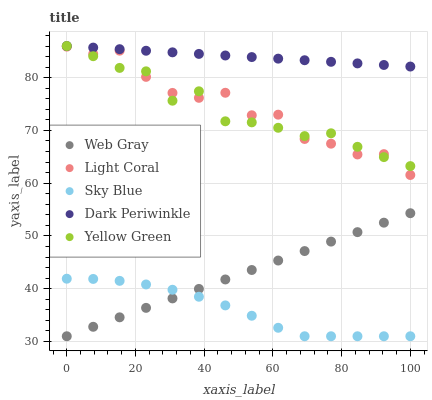Does Sky Blue have the minimum area under the curve?
Answer yes or no. Yes. Does Dark Periwinkle have the maximum area under the curve?
Answer yes or no. Yes. Does Web Gray have the minimum area under the curve?
Answer yes or no. No. Does Web Gray have the maximum area under the curve?
Answer yes or no. No. Is Dark Periwinkle the smoothest?
Answer yes or no. Yes. Is Light Coral the roughest?
Answer yes or no. Yes. Is Sky Blue the smoothest?
Answer yes or no. No. Is Sky Blue the roughest?
Answer yes or no. No. Does Sky Blue have the lowest value?
Answer yes or no. Yes. Does Dark Periwinkle have the lowest value?
Answer yes or no. No. Does Yellow Green have the highest value?
Answer yes or no. Yes. Does Web Gray have the highest value?
Answer yes or no. No. Is Sky Blue less than Dark Periwinkle?
Answer yes or no. Yes. Is Dark Periwinkle greater than Sky Blue?
Answer yes or no. Yes. Does Sky Blue intersect Web Gray?
Answer yes or no. Yes. Is Sky Blue less than Web Gray?
Answer yes or no. No. Is Sky Blue greater than Web Gray?
Answer yes or no. No. Does Sky Blue intersect Dark Periwinkle?
Answer yes or no. No. 